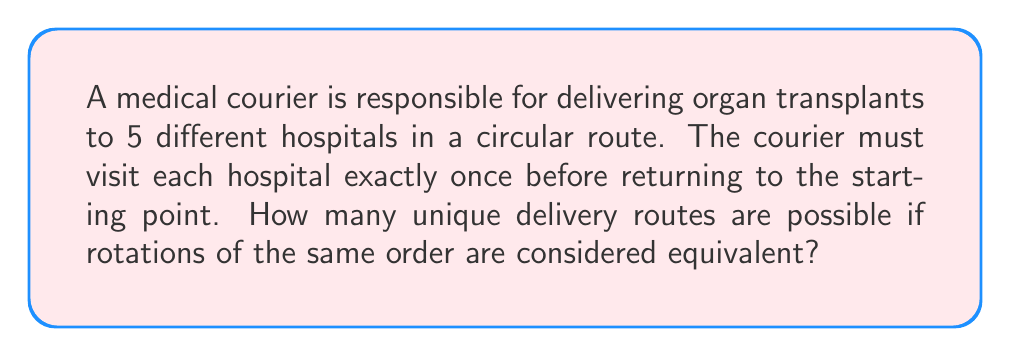Provide a solution to this math problem. To solve this problem, we need to use the concept of cyclic groups from Ring theory.

1) First, let's consider the total number of permutations for 5 hospitals:
   $$5! = 5 \times 4 \times 3 \times 2 \times 1 = 120$$

2) However, in this case, we consider rotations of the same order to be equivalent. This is because the courier returns to the starting point, so the starting hospital doesn't matter.

3) In cyclic group theory, this is equivalent to considering the cyclic group $C_5$ (cyclic group of order 5).

4) The number of unique routes is equal to the number of elements in the quotient group of the symmetric group $S_5$ by the cyclic group $C_5$:

   $$\frac{|S_5|}{|C_5|} = \frac{5!}{5} = \frac{120}{5} = 24$$

5) This result can be interpreted as follows: for each unique route, there are 5 equivalent rotations (one starting from each hospital), so we divide the total number of permutations by 5.

Therefore, there are 24 unique delivery routes for the medical courier.
Answer: 24 unique delivery routes 